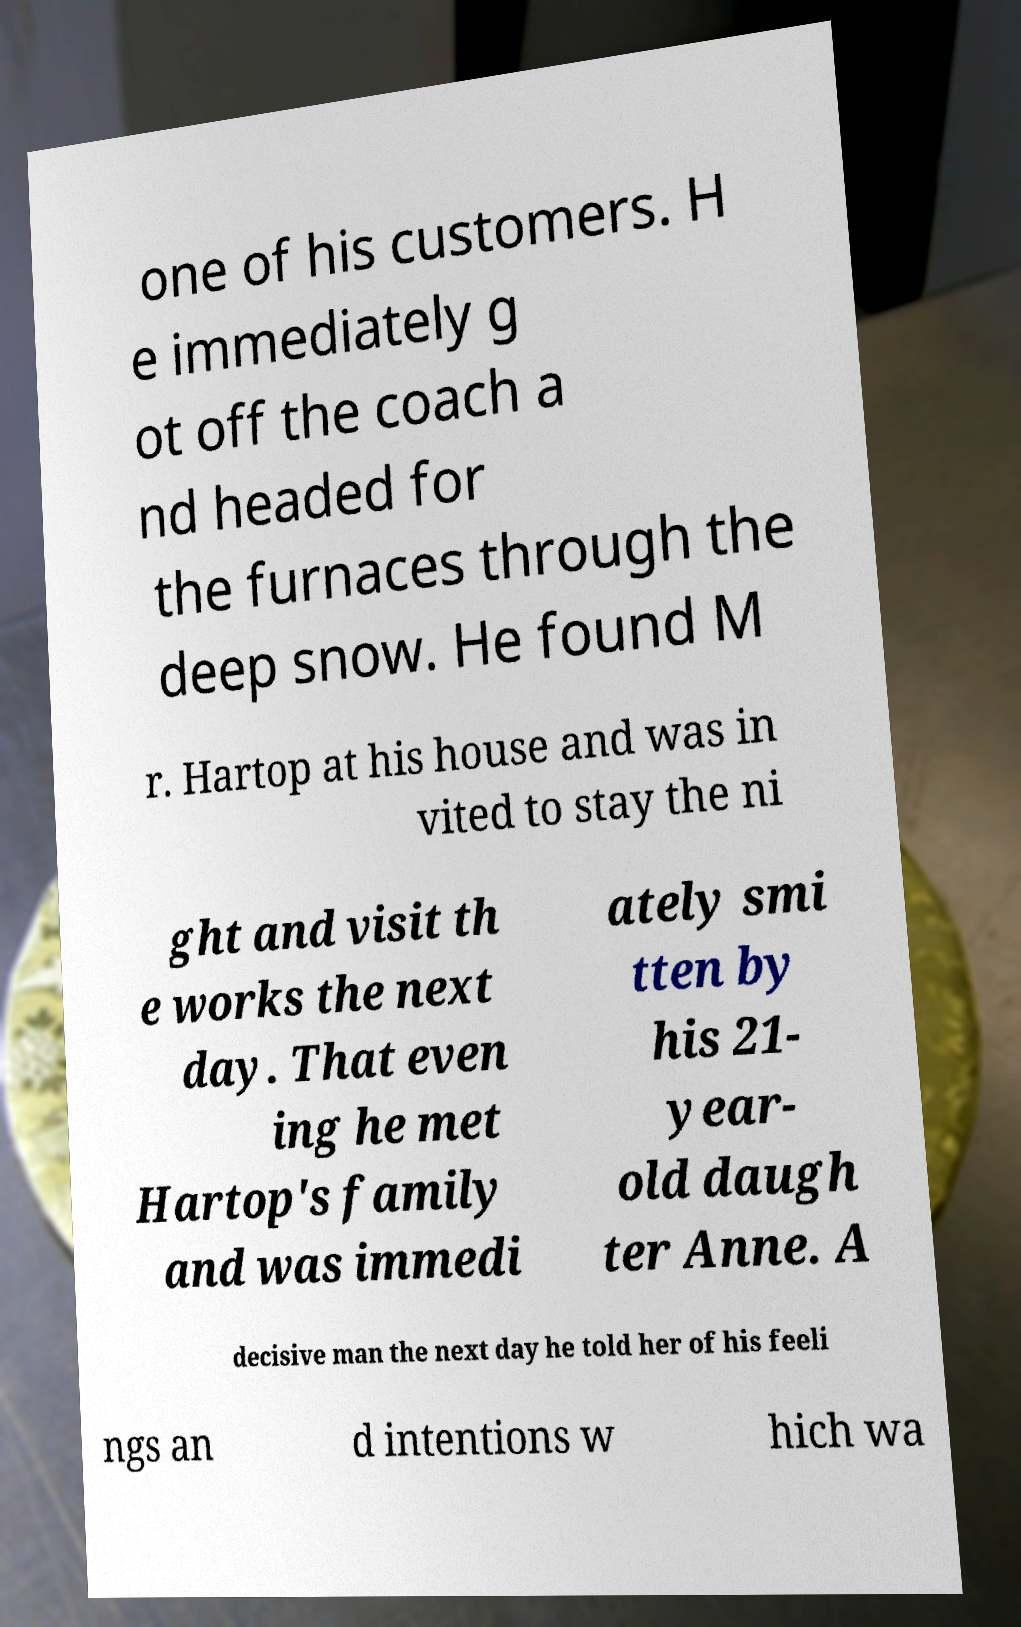For documentation purposes, I need the text within this image transcribed. Could you provide that? one of his customers. H e immediately g ot off the coach a nd headed for the furnaces through the deep snow. He found M r. Hartop at his house and was in vited to stay the ni ght and visit th e works the next day. That even ing he met Hartop's family and was immedi ately smi tten by his 21- year- old daugh ter Anne. A decisive man the next day he told her of his feeli ngs an d intentions w hich wa 